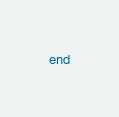Convert code to text. <code><loc_0><loc_0><loc_500><loc_500><_Ruby_>
end

</code> 